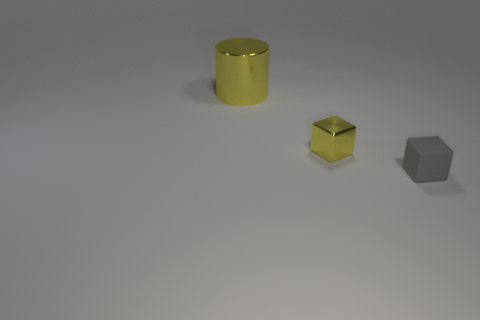Are there any other things that have the same size as the metallic cylinder?
Provide a short and direct response. No. Are there any gray rubber things that have the same size as the yellow shiny cube?
Your response must be concise. Yes. There is a rubber thing that is the same size as the yellow metal block; what is its shape?
Offer a terse response. Cube. What number of other objects are there of the same color as the rubber thing?
Your answer should be compact. 0. There is a thing that is both behind the tiny gray object and to the right of the big cylinder; what shape is it?
Keep it short and to the point. Cube. Are there any gray matte objects on the left side of the metal thing that is in front of the metal thing that is behind the tiny yellow cube?
Provide a short and direct response. No. What number of other things are there of the same material as the big thing
Keep it short and to the point. 1. What number of rubber cylinders are there?
Offer a terse response. 0. How many things are tiny yellow things or yellow metallic things that are on the right side of the big shiny thing?
Make the answer very short. 1. Is there anything else that is the same shape as the big yellow object?
Make the answer very short. No. 